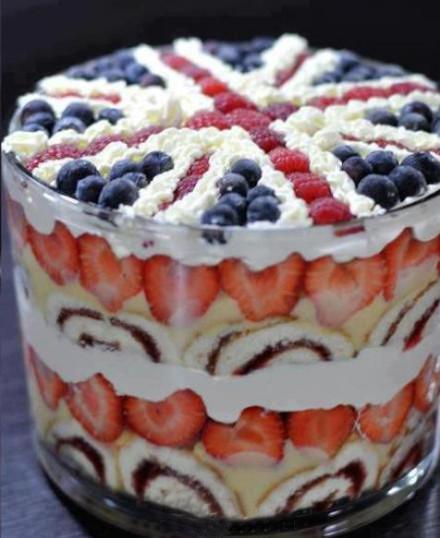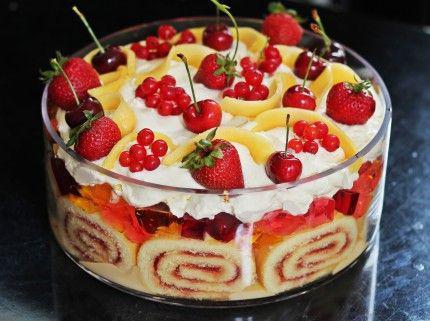The first image is the image on the left, the second image is the image on the right. Assess this claim about the two images: "in one of the images, there is a strawberry nestled on top of a pile of blueberries on a cake". Correct or not? Answer yes or no. No. The first image is the image on the left, the second image is the image on the right. Assess this claim about the two images: "In one image, a large dessert in a clear footed bowl is topped with a whole strawberry centered on a mound of blueberries, which are ringed by strawberry slices.". Correct or not? Answer yes or no. No. 